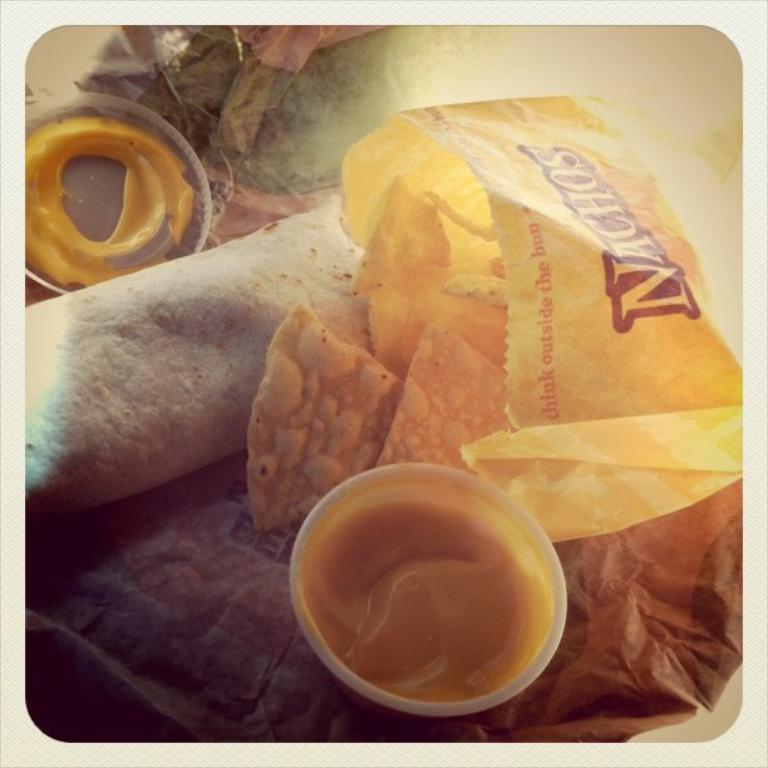What is in the image that can hold food or liquids? There is a bowl in the image. What type of items can be seen in the image that are typically used for writing or reading? There are papers in the image. What can be seen in the image that might be used to cover or protect the contents of the bowl? There is a lid in the image. What other items are present in the image that are not specified in detail? There are some unspecified objects in the image. Where is the cave located in the image? There is no cave present in the image. What type of furniture can be seen in the image? There is no furniture present in the image. 